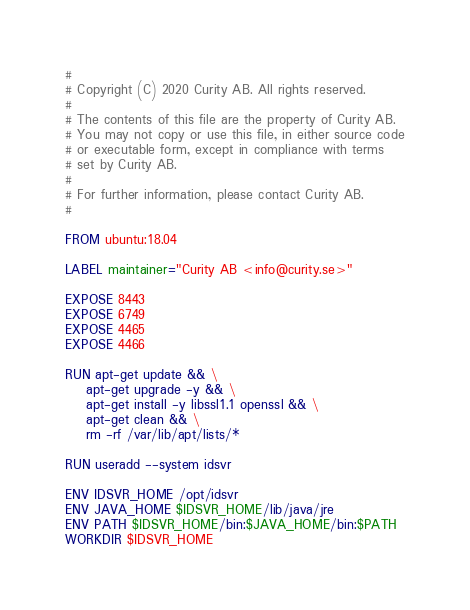<code> <loc_0><loc_0><loc_500><loc_500><_Dockerfile_>#
# Copyright (C) 2020 Curity AB. All rights reserved.
#
# The contents of this file are the property of Curity AB.
# You may not copy or use this file, in either source code
# or executable form, except in compliance with terms
# set by Curity AB.
#
# For further information, please contact Curity AB.
#

FROM ubuntu:18.04

LABEL maintainer="Curity AB <info@curity.se>"

EXPOSE 8443
EXPOSE 6749
EXPOSE 4465
EXPOSE 4466

RUN apt-get update && \
	apt-get upgrade -y && \
	apt-get install -y libssl1.1 openssl && \
	apt-get clean && \
	rm -rf /var/lib/apt/lists/* 

RUN useradd --system idsvr

ENV IDSVR_HOME /opt/idsvr
ENV JAVA_HOME $IDSVR_HOME/lib/java/jre
ENV PATH $IDSVR_HOME/bin:$JAVA_HOME/bin:$PATH
WORKDIR $IDSVR_HOME
</code> 